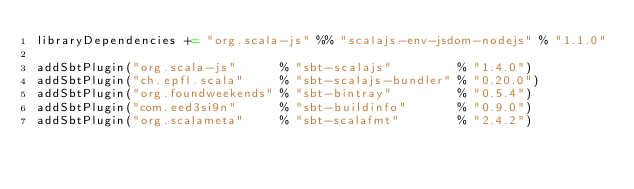<code> <loc_0><loc_0><loc_500><loc_500><_Scala_>libraryDependencies += "org.scala-js" %% "scalajs-env-jsdom-nodejs" % "1.1.0"

addSbtPlugin("org.scala-js"      % "sbt-scalajs"         % "1.4.0")
addSbtPlugin("ch.epfl.scala"     % "sbt-scalajs-bundler" % "0.20.0")
addSbtPlugin("org.foundweekends" % "sbt-bintray"         % "0.5.4")
addSbtPlugin("com.eed3si9n"      % "sbt-buildinfo"       % "0.9.0")
addSbtPlugin("org.scalameta"     % "sbt-scalafmt"        % "2.4.2")
</code> 